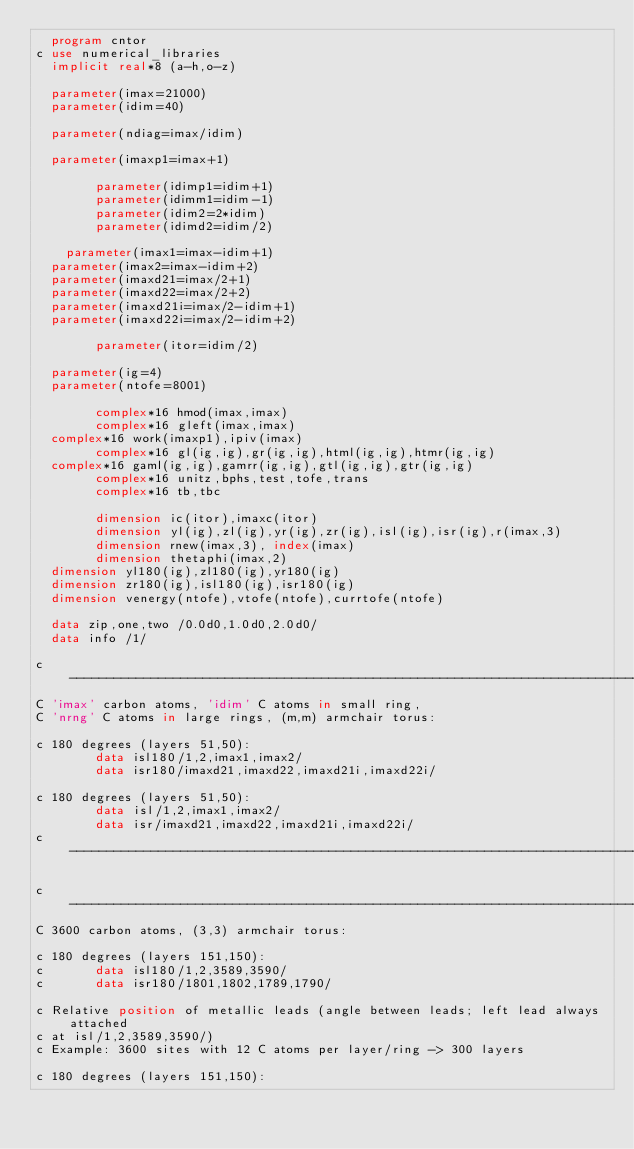Convert code to text. <code><loc_0><loc_0><loc_500><loc_500><_FORTRAN_>	program cntor
c	use numerical_libraries
	implicit real*8 (a-h,o-z)
	
	parameter(imax=21000)	
	parameter(idim=40)
	
	parameter(ndiag=imax/idim)
	
	parameter(imaxp1=imax+1)
	 		
      	parameter(idimp1=idim+1)
      	parameter(idimm1=idim-1)
      	parameter(idim2=2*idim)
      	parameter(idimd2=idim/2)

  	parameter(imax1=imax-idim+1)
	parameter(imax2=imax-idim+2)
	parameter(imaxd21=imax/2+1)
	parameter(imaxd22=imax/2+2)
	parameter(imaxd21i=imax/2-idim+1)
	parameter(imaxd22i=imax/2-idim+2)	

      	parameter(itor=idim/2)
      		 
	parameter(ig=4)
	parameter(ntofe=8001)	

      	complex*16 hmod(imax,imax)
      	complex*16 gleft(imax,imax)
	complex*16 work(imaxp1),ipiv(imax)
      	complex*16 gl(ig,ig),gr(ig,ig),html(ig,ig),htmr(ig,ig)
	complex*16 gaml(ig,ig),gamrr(ig,ig),gtl(ig,ig),gtr(ig,ig)
      	complex*16 unitz,bphs,test,tofe,trans
      	complex*16 tb,tbc

      	dimension ic(itor),imaxc(itor)
      	dimension yl(ig),zl(ig),yr(ig),zr(ig),isl(ig),isr(ig),r(imax,3)
        dimension rnew(imax,3), index(imax)
        dimension thetaphi(imax,2)
	dimension yl180(ig),zl180(ig),yr180(ig)
	dimension zr180(ig),isl180(ig),isr180(ig)
 	dimension venergy(ntofe),vtofe(ntofe),currtofe(ntofe)		
 	     	        
	data zip,one,two /0.0d0,1.0d0,2.0d0/
	data info /1/

c---------------------------------------------------------------------------------------
C 'imax' carbon atoms, 'idim' C atoms in small ring, 
C 'nrng' C atoms in large rings, (m,m) armchair torus:

c 180 degrees (layers 51,50):
      	data isl180/1,2,imax1,imax2/
      	data isr180/imaxd21,imaxd22,imaxd21i,imaxd22i/
		
c 180 degrees (layers 51,50):
      	data isl/1,2,imax1,imax2/
      	data isr/imaxd21,imaxd22,imaxd21i,imaxd22i/
c--------------------------------------------------------------------------------------- 
 	
c---------------------------------------------------------------------------------------
C 3600 carbon atoms, (3,3) armchair torus:

c 180 degrees (layers 151,150):
c      	data isl180/1,2,3589,3590/
c      	data isr180/1801,1802,1789,1790/

c Relative position of metallic leads (angle between leads; left lead always attached 
c at isl/1,2,3589,3590/)
c Example: 3600 sites with 12 C atoms per layer/ring -> 300 layers
		
c 180 degrees (layers 151,150):</code> 